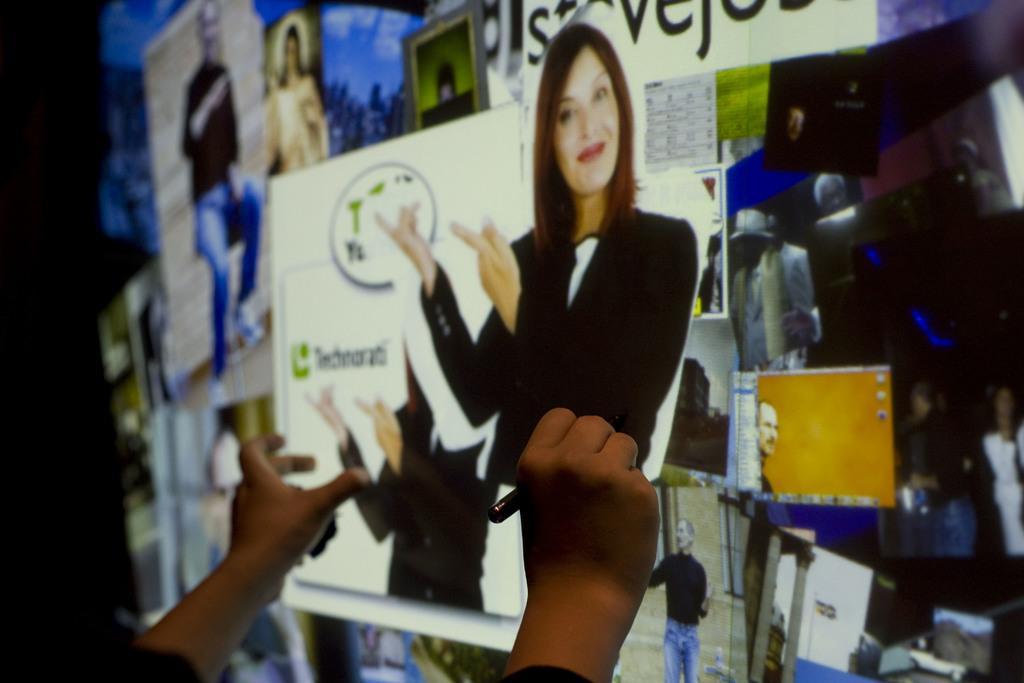In one or two sentences, can you explain what this image depicts? In the image we can see there is a projector screen on which there are posters and there is a person holding pen his hand. 